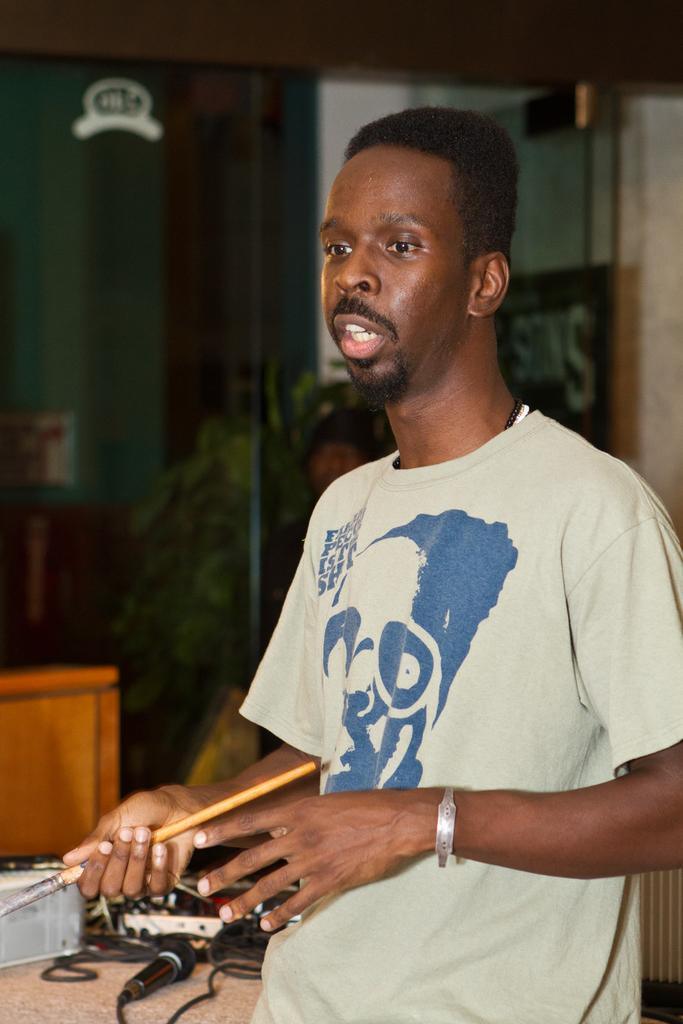Describe this image in one or two sentences. In this image we can see a man wearing the t shirt and holding an object and standing. In the background we can see the mike with the wire on the counter. We can also see the wooden object on the left. There is also a person in the background. We can also see the glass door. 